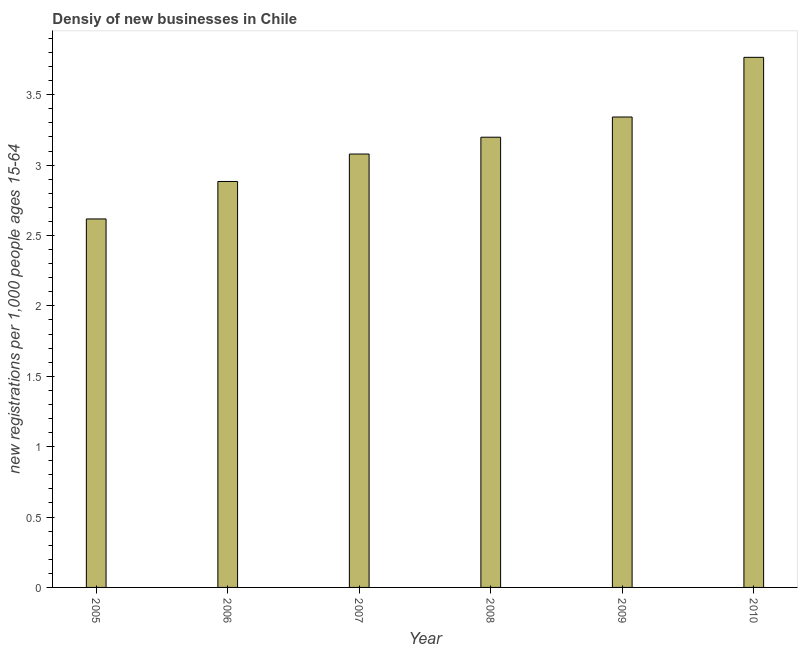Does the graph contain any zero values?
Your response must be concise. No. Does the graph contain grids?
Give a very brief answer. No. What is the title of the graph?
Make the answer very short. Densiy of new businesses in Chile. What is the label or title of the Y-axis?
Provide a short and direct response. New registrations per 1,0 people ages 15-64. What is the density of new business in 2009?
Keep it short and to the point. 3.34. Across all years, what is the maximum density of new business?
Ensure brevity in your answer.  3.77. Across all years, what is the minimum density of new business?
Your answer should be very brief. 2.62. In which year was the density of new business maximum?
Provide a succinct answer. 2010. In which year was the density of new business minimum?
Your answer should be very brief. 2005. What is the sum of the density of new business?
Your response must be concise. 18.88. What is the difference between the density of new business in 2006 and 2008?
Your response must be concise. -0.31. What is the average density of new business per year?
Give a very brief answer. 3.15. What is the median density of new business?
Offer a very short reply. 3.14. In how many years, is the density of new business greater than 1.9 ?
Your answer should be very brief. 6. Do a majority of the years between 2009 and 2010 (inclusive) have density of new business greater than 1.6 ?
Provide a succinct answer. Yes. What is the ratio of the density of new business in 2005 to that in 2008?
Your response must be concise. 0.82. What is the difference between the highest and the second highest density of new business?
Offer a very short reply. 0.42. What is the difference between the highest and the lowest density of new business?
Offer a terse response. 1.15. In how many years, is the density of new business greater than the average density of new business taken over all years?
Make the answer very short. 3. How many bars are there?
Give a very brief answer. 6. Are all the bars in the graph horizontal?
Offer a very short reply. No. How many years are there in the graph?
Keep it short and to the point. 6. What is the new registrations per 1,000 people ages 15-64 in 2005?
Ensure brevity in your answer.  2.62. What is the new registrations per 1,000 people ages 15-64 of 2006?
Your answer should be compact. 2.88. What is the new registrations per 1,000 people ages 15-64 of 2007?
Your answer should be compact. 3.08. What is the new registrations per 1,000 people ages 15-64 in 2008?
Keep it short and to the point. 3.2. What is the new registrations per 1,000 people ages 15-64 of 2009?
Make the answer very short. 3.34. What is the new registrations per 1,000 people ages 15-64 of 2010?
Ensure brevity in your answer.  3.77. What is the difference between the new registrations per 1,000 people ages 15-64 in 2005 and 2006?
Provide a short and direct response. -0.27. What is the difference between the new registrations per 1,000 people ages 15-64 in 2005 and 2007?
Your answer should be compact. -0.46. What is the difference between the new registrations per 1,000 people ages 15-64 in 2005 and 2008?
Ensure brevity in your answer.  -0.58. What is the difference between the new registrations per 1,000 people ages 15-64 in 2005 and 2009?
Provide a short and direct response. -0.72. What is the difference between the new registrations per 1,000 people ages 15-64 in 2005 and 2010?
Make the answer very short. -1.15. What is the difference between the new registrations per 1,000 people ages 15-64 in 2006 and 2007?
Your answer should be very brief. -0.19. What is the difference between the new registrations per 1,000 people ages 15-64 in 2006 and 2008?
Offer a very short reply. -0.31. What is the difference between the new registrations per 1,000 people ages 15-64 in 2006 and 2009?
Keep it short and to the point. -0.46. What is the difference between the new registrations per 1,000 people ages 15-64 in 2006 and 2010?
Offer a very short reply. -0.88. What is the difference between the new registrations per 1,000 people ages 15-64 in 2007 and 2008?
Provide a succinct answer. -0.12. What is the difference between the new registrations per 1,000 people ages 15-64 in 2007 and 2009?
Offer a very short reply. -0.26. What is the difference between the new registrations per 1,000 people ages 15-64 in 2007 and 2010?
Your answer should be very brief. -0.69. What is the difference between the new registrations per 1,000 people ages 15-64 in 2008 and 2009?
Your answer should be compact. -0.14. What is the difference between the new registrations per 1,000 people ages 15-64 in 2008 and 2010?
Offer a terse response. -0.57. What is the difference between the new registrations per 1,000 people ages 15-64 in 2009 and 2010?
Ensure brevity in your answer.  -0.42. What is the ratio of the new registrations per 1,000 people ages 15-64 in 2005 to that in 2006?
Provide a short and direct response. 0.91. What is the ratio of the new registrations per 1,000 people ages 15-64 in 2005 to that in 2008?
Your answer should be very brief. 0.82. What is the ratio of the new registrations per 1,000 people ages 15-64 in 2005 to that in 2009?
Provide a succinct answer. 0.78. What is the ratio of the new registrations per 1,000 people ages 15-64 in 2005 to that in 2010?
Provide a short and direct response. 0.69. What is the ratio of the new registrations per 1,000 people ages 15-64 in 2006 to that in 2007?
Ensure brevity in your answer.  0.94. What is the ratio of the new registrations per 1,000 people ages 15-64 in 2006 to that in 2008?
Keep it short and to the point. 0.9. What is the ratio of the new registrations per 1,000 people ages 15-64 in 2006 to that in 2009?
Provide a short and direct response. 0.86. What is the ratio of the new registrations per 1,000 people ages 15-64 in 2006 to that in 2010?
Offer a terse response. 0.77. What is the ratio of the new registrations per 1,000 people ages 15-64 in 2007 to that in 2008?
Ensure brevity in your answer.  0.96. What is the ratio of the new registrations per 1,000 people ages 15-64 in 2007 to that in 2009?
Your response must be concise. 0.92. What is the ratio of the new registrations per 1,000 people ages 15-64 in 2007 to that in 2010?
Ensure brevity in your answer.  0.82. What is the ratio of the new registrations per 1,000 people ages 15-64 in 2008 to that in 2010?
Provide a succinct answer. 0.85. What is the ratio of the new registrations per 1,000 people ages 15-64 in 2009 to that in 2010?
Offer a terse response. 0.89. 